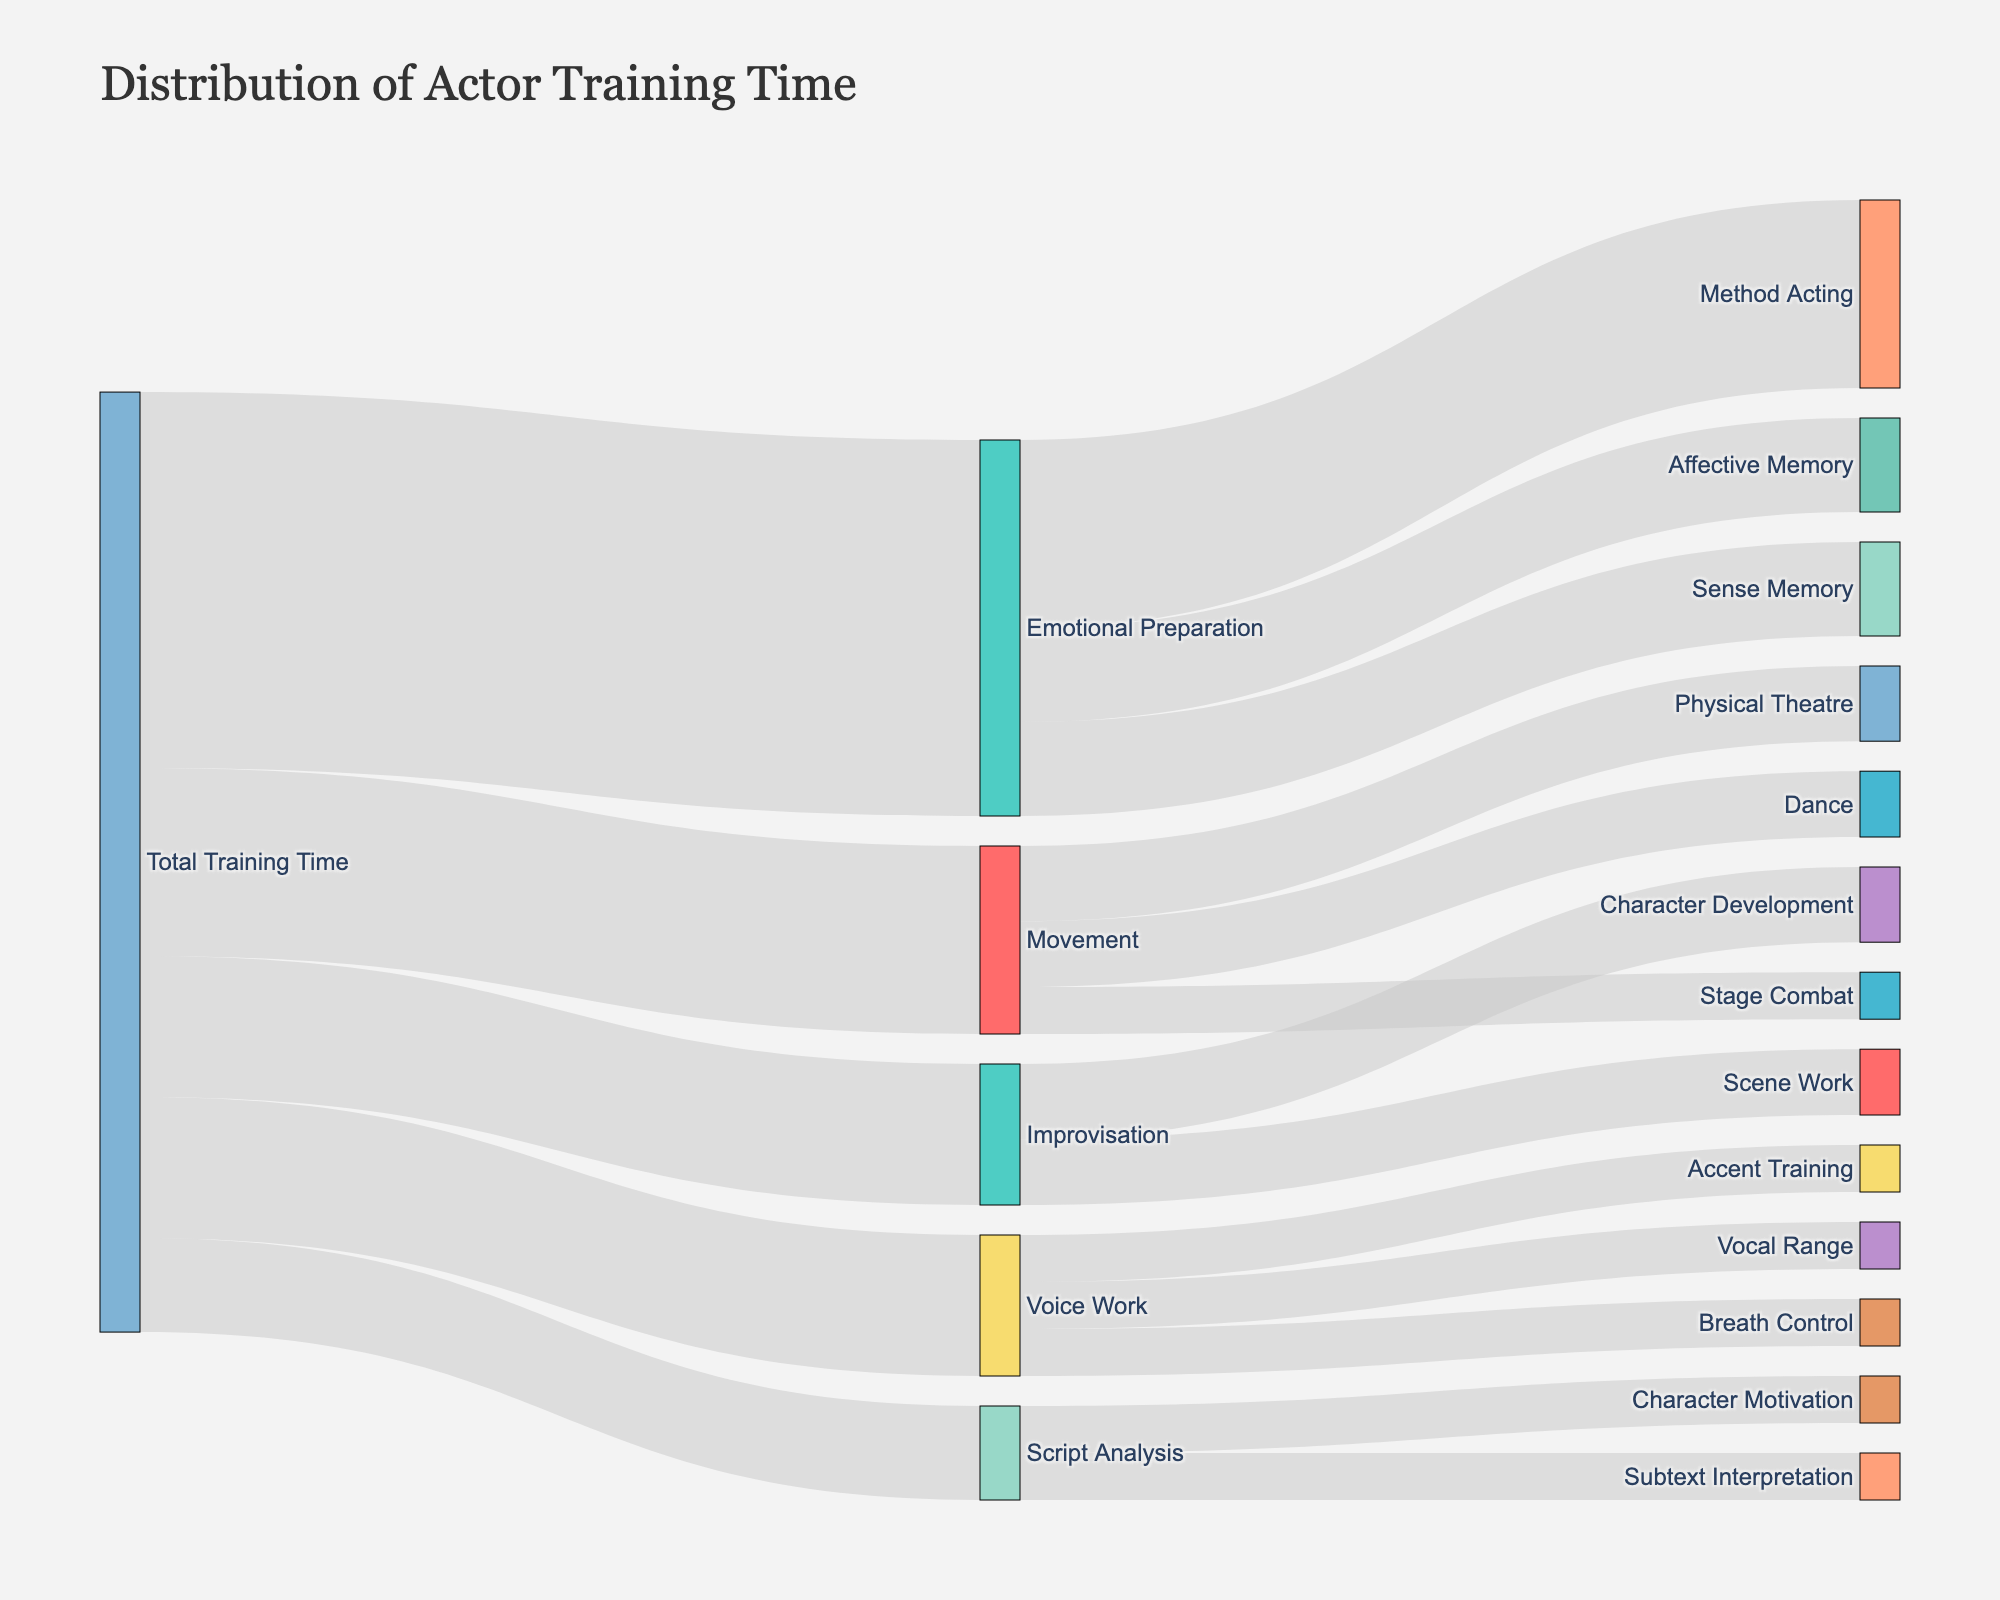What is the title of the Sankey diagram? The title of the diagram is displayed at the top, usually in larger text.
Answer: Distribution of Actor Training Time How much total training time is dedicated to Movement? From the "Total Training Time" node, follow the linkage to the "Movement" node and read the value.
Answer: 20 Which aspect of actor training receives the largest amount of time? Look at the values connected to the "Total Training Time" node and find the largest number.
Answer: Emotional Preparation What's the combined value of time spent on Method Acting and Sense Memory? Find the values for Method Acting and Sense Memory under Emotional Preparation and add them up (20 + 10).
Answer: 30 How does the time spent on Script Analysis compare to Improvisation? Compare the values of Script Analysis and Improvisation linked to Total Training Time (10 for Script Analysis and 15 for Improvisation).
Answer: Improvisation has more (15 > 10) What's the percentage of training time spent on Emotional Preparation out of the total time? Sum the values under Total Training Time (15 + 20 + 40 + 10 + 15 = 100), then compute the percentage for Emotional Preparation (40/100 * 100%).
Answer: 40% Which training aspect has the least dedication within Movement? Examine the values under Movement (Physical Theatre, Dance, Stage Combat). Stage Combat has the smallest value.
Answer: Stage Combat What is the total amount of time spent on Voice Work aspects (Breath Control, Vocal Range, Accent Training)? Sum the values under Voice Work (5 + 5 + 5).
Answer: 15 Is there any aspect of training that gets an equal amount of time as Accent Training? Compare the value of Accent Training (5) with other detailed training aspects and find the one(s) with the same value.
Answer: Breath Control, Vocal Range, Character Motivation, Subtext Interpretation How much more time is spent on Emotional Preparation compared to the combined time for Script Analysis and Improvisation? Calculate the combined time for Script Analysis and Improvisation (10 + 15 = 25) and subtract this from the time spent on Emotional Preparation (40 - 25).
Answer: 15 